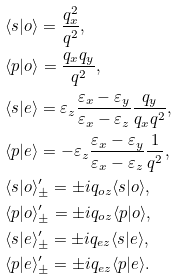Convert formula to latex. <formula><loc_0><loc_0><loc_500><loc_500>& \langle s | o \rangle = \frac { q _ { x } ^ { 2 } } { q ^ { 2 } } , \\ & \langle p | o \rangle = \frac { q _ { x } q _ { y } } { q ^ { 2 } } , \\ & \langle s | e \rangle = \varepsilon _ { z } \frac { \varepsilon _ { x } - \varepsilon _ { y } } { \varepsilon _ { x } - \varepsilon _ { z } } \frac { q _ { y } } { q _ { x } q ^ { 2 } } , \\ & \langle p | e \rangle = - \varepsilon _ { z } \frac { \varepsilon _ { x } - \varepsilon _ { y } } { \varepsilon _ { x } - \varepsilon _ { z } } \frac { 1 } { q ^ { 2 } } , \\ & \langle s | o \rangle ^ { \prime } _ { \pm } = \pm i q _ { o z } \langle s | o \rangle , \\ & \langle p | o \rangle ^ { \prime } _ { \pm } = \pm i q _ { o z } \langle p | o \rangle , \\ & \langle s | e \rangle ^ { \prime } _ { \pm } = \pm i q _ { e z } \langle s | e \rangle , \\ & \langle p | e \rangle ^ { \prime } _ { \pm } = \pm i q _ { e z } \langle p | e \rangle .</formula> 